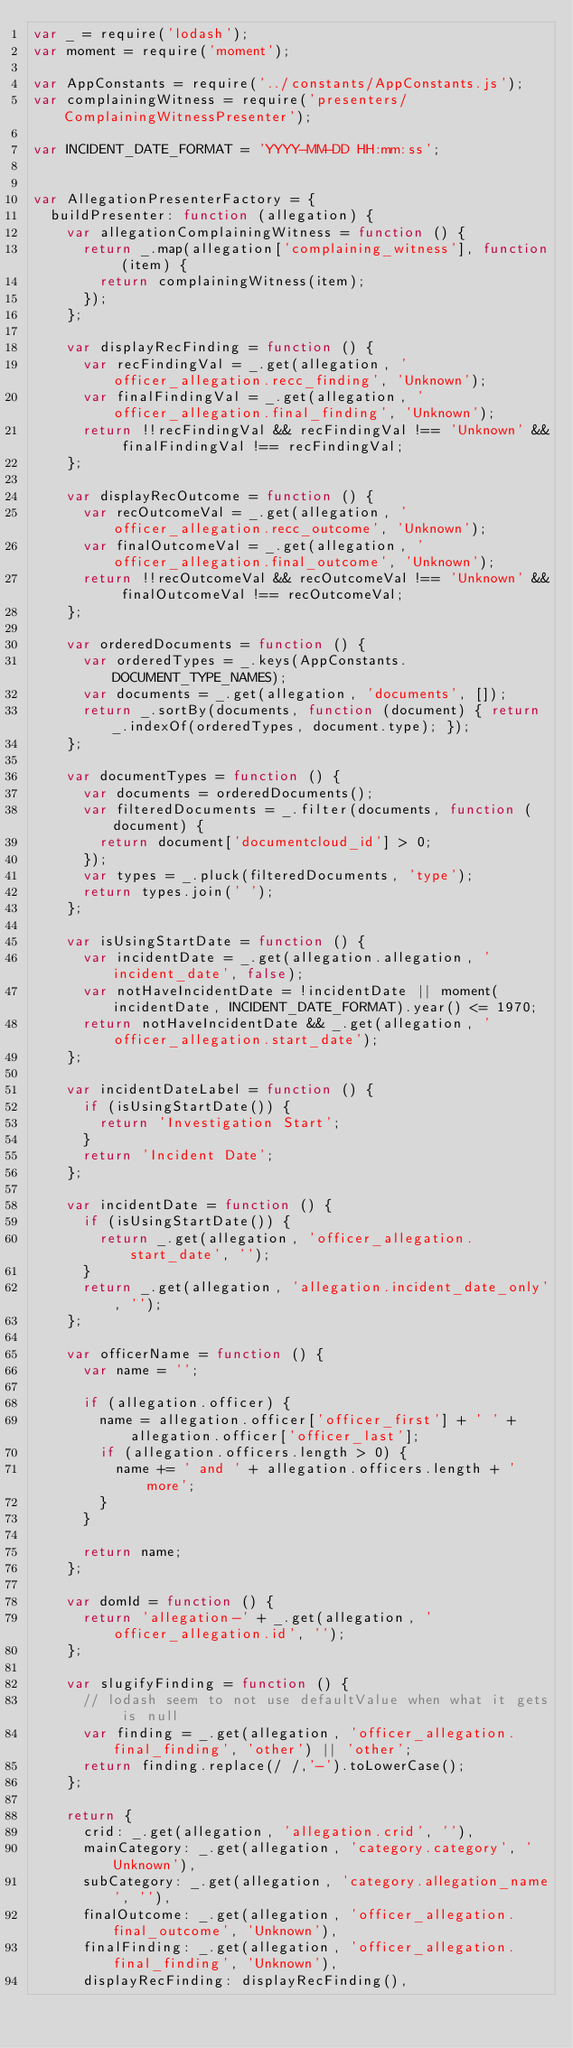Convert code to text. <code><loc_0><loc_0><loc_500><loc_500><_JavaScript_>var _ = require('lodash');
var moment = require('moment');

var AppConstants = require('../constants/AppConstants.js');
var complainingWitness = require('presenters/ComplainingWitnessPresenter');

var INCIDENT_DATE_FORMAT = 'YYYY-MM-DD HH:mm:ss';


var AllegationPresenterFactory = {
  buildPresenter: function (allegation) {
    var allegationComplainingWitness = function () {
      return _.map(allegation['complaining_witness'], function (item) {
        return complainingWitness(item);
      });
    };

    var displayRecFinding = function () {
      var recFindingVal = _.get(allegation, 'officer_allegation.recc_finding', 'Unknown');
      var finalFindingVal = _.get(allegation, 'officer_allegation.final_finding', 'Unknown');
      return !!recFindingVal && recFindingVal !== 'Unknown' && finalFindingVal !== recFindingVal;
    };

    var displayRecOutcome = function () {
      var recOutcomeVal = _.get(allegation, 'officer_allegation.recc_outcome', 'Unknown');
      var finalOutcomeVal = _.get(allegation, 'officer_allegation.final_outcome', 'Unknown');
      return !!recOutcomeVal && recOutcomeVal !== 'Unknown' && finalOutcomeVal !== recOutcomeVal;
    };

    var orderedDocuments = function () {
      var orderedTypes = _.keys(AppConstants.DOCUMENT_TYPE_NAMES);
      var documents = _.get(allegation, 'documents', []);
      return _.sortBy(documents, function (document) { return _.indexOf(orderedTypes, document.type); });
    };

    var documentTypes = function () {
      var documents = orderedDocuments();
      var filteredDocuments = _.filter(documents, function (document) {
        return document['documentcloud_id'] > 0;
      });
      var types = _.pluck(filteredDocuments, 'type');
      return types.join(' ');
    };

    var isUsingStartDate = function () {
      var incidentDate = _.get(allegation.allegation, 'incident_date', false);
      var notHaveIncidentDate = !incidentDate || moment(incidentDate, INCIDENT_DATE_FORMAT).year() <= 1970;
      return notHaveIncidentDate && _.get(allegation, 'officer_allegation.start_date');
    };

    var incidentDateLabel = function () {
      if (isUsingStartDate()) {
        return 'Investigation Start';
      }
      return 'Incident Date';
    };

    var incidentDate = function () {
      if (isUsingStartDate()) {
        return _.get(allegation, 'officer_allegation.start_date', '');
      }
      return _.get(allegation, 'allegation.incident_date_only', '');
    };

    var officerName = function () {
      var name = '';

      if (allegation.officer) {
        name = allegation.officer['officer_first'] + ' ' + allegation.officer['officer_last'];
        if (allegation.officers.length > 0) {
          name += ' and ' + allegation.officers.length + ' more';
        }
      }

      return name;
    };

    var domId = function () {
      return 'allegation-' + _.get(allegation, 'officer_allegation.id', '');
    };

    var slugifyFinding = function () {
      // lodash seem to not use defaultValue when what it gets is null
      var finding = _.get(allegation, 'officer_allegation.final_finding', 'other') || 'other';
      return finding.replace(/ /,'-').toLowerCase();
    };

    return {
      crid: _.get(allegation, 'allegation.crid', ''),
      mainCategory: _.get(allegation, 'category.category', 'Unknown'),
      subCategory: _.get(allegation, 'category.allegation_name', ''),
      finalOutcome: _.get(allegation, 'officer_allegation.final_outcome', 'Unknown'),
      finalFinding: _.get(allegation, 'officer_allegation.final_finding', 'Unknown'),
      displayRecFinding: displayRecFinding(),</code> 